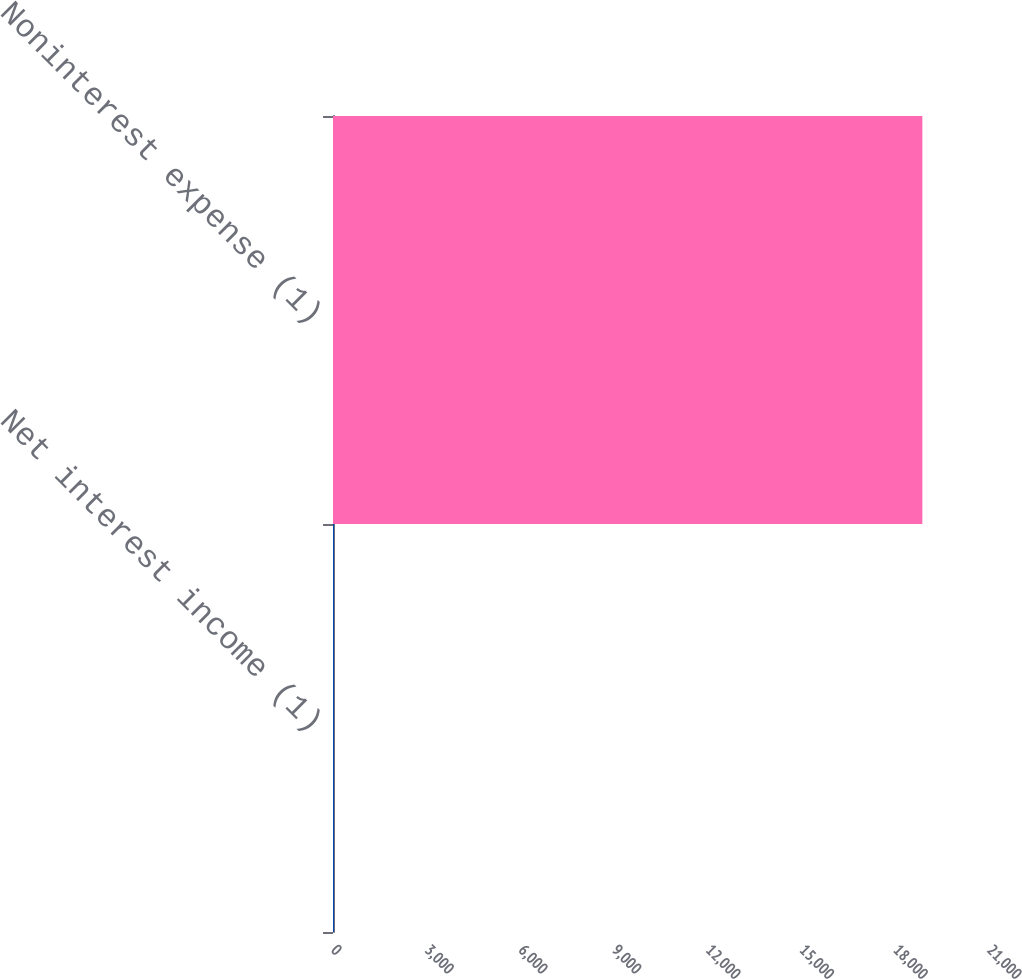Convert chart to OTSL. <chart><loc_0><loc_0><loc_500><loc_500><bar_chart><fcel>Net interest income (1)<fcel>Noninterest expense (1)<nl><fcel>33<fcel>18867<nl></chart> 